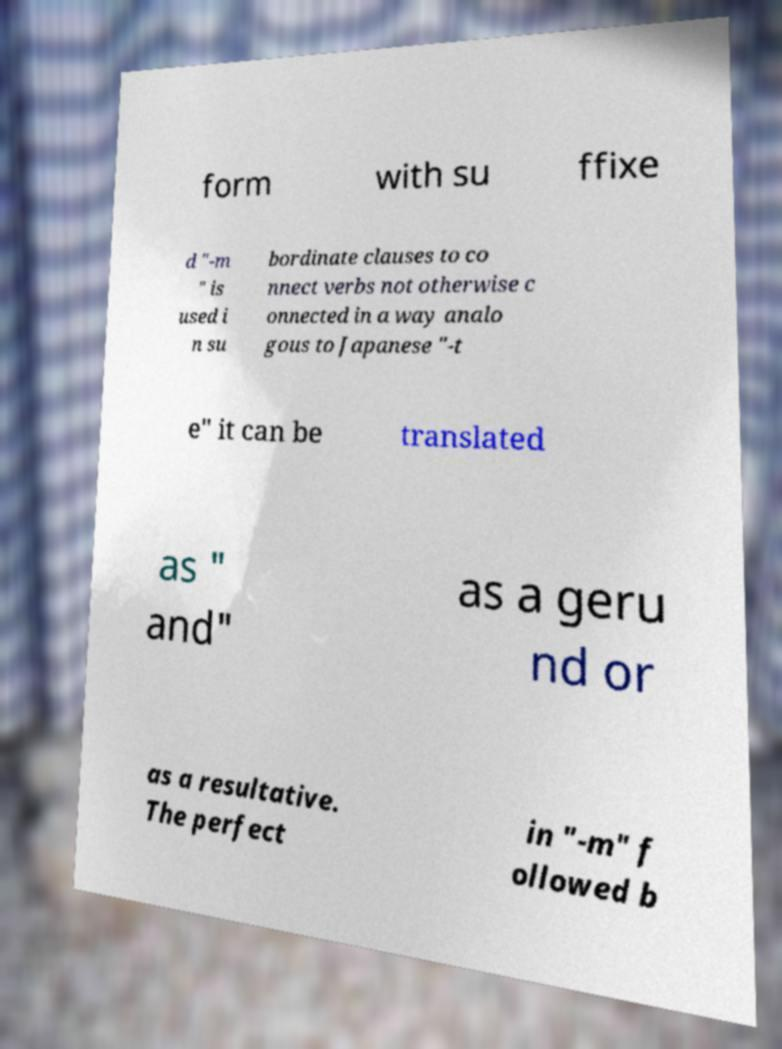What messages or text are displayed in this image? I need them in a readable, typed format. form with su ffixe d "-m " is used i n su bordinate clauses to co nnect verbs not otherwise c onnected in a way analo gous to Japanese "-t e" it can be translated as " and" as a geru nd or as a resultative. The perfect in "-m" f ollowed b 